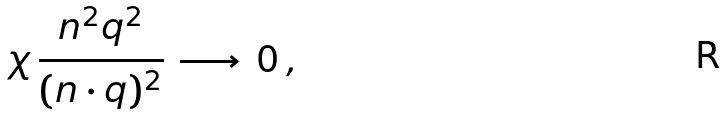<formula> <loc_0><loc_0><loc_500><loc_500>\chi \, \frac { n ^ { 2 } q ^ { 2 } } { ( n \cdot q ) ^ { 2 } } \, \longrightarrow \, 0 \, ,</formula> 